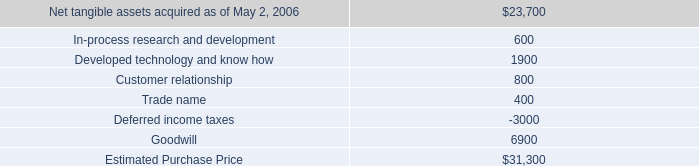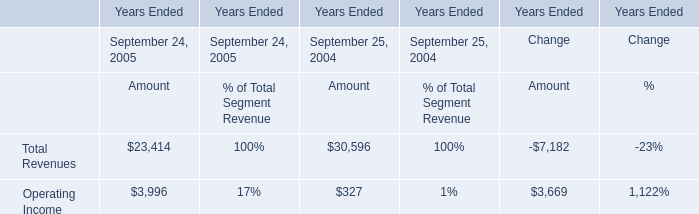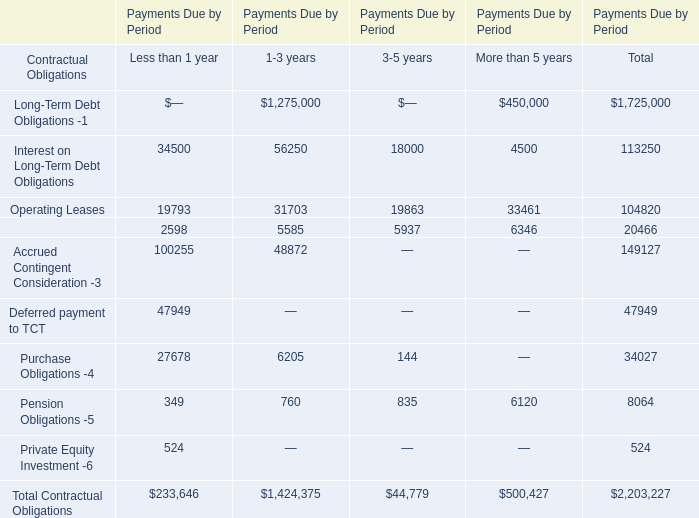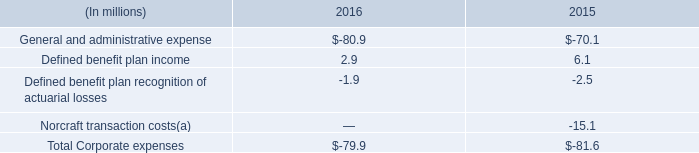In the section with the most Interest on Long-Term Debt Obligations, what is the growth rate of Financing Leases -2? 
Computations: ((5585 - 2598) / 2598)
Answer: 1.14973. 